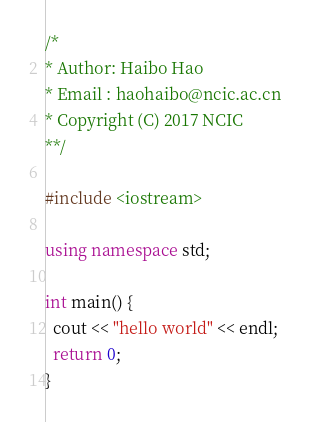Convert code to text. <code><loc_0><loc_0><loc_500><loc_500><_C++_>/*
* Author: Haibo Hao
* Email : haohaibo@ncic.ac.cn
* Copyright (C) 2017 NCIC
**/

#include <iostream>

using namespace std;

int main() {
  cout << "hello world" << endl;
  return 0;
}
</code> 